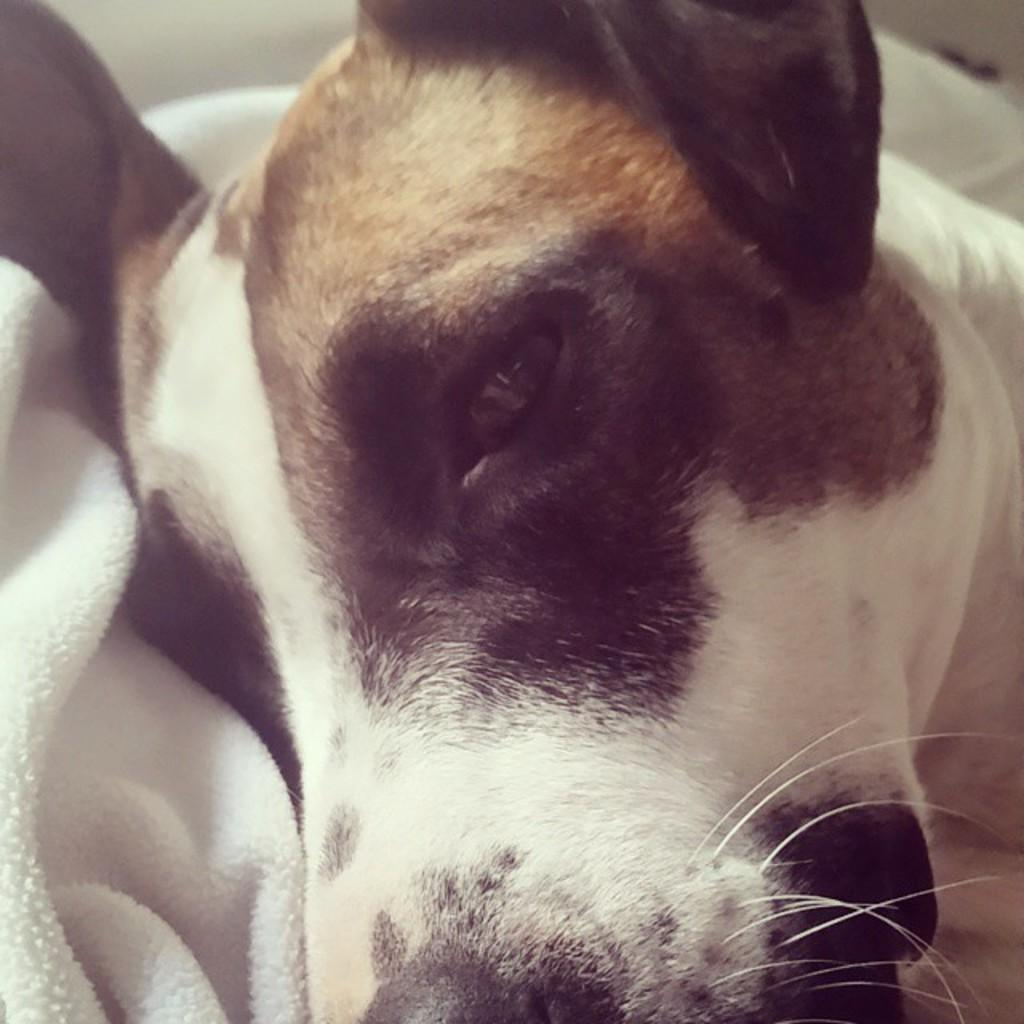What is the focus of the image? The image is a zoomed in picture. What can be seen in the foreground of the image? There is a dog in the foreground of the image. What object is visible in the image? There is a white color towel in the image. What month is depicted in the image? There is no indication of a specific month in the image; it features a dog and a white towel. What type of skin condition can be seen on the dog in the image? There is no indication of any skin condition on the dog in the image. 